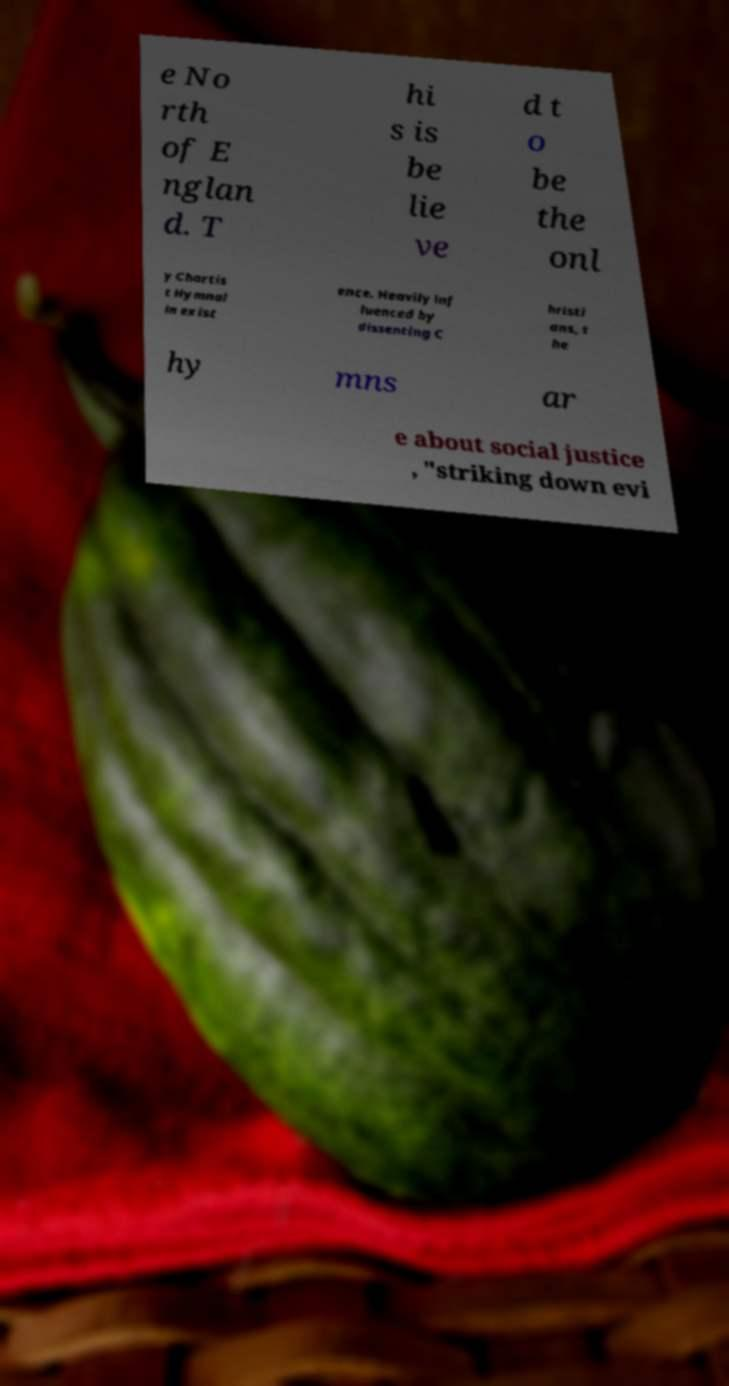For documentation purposes, I need the text within this image transcribed. Could you provide that? e No rth of E nglan d. T hi s is be lie ve d t o be the onl y Chartis t Hymnal in exist ence. Heavily inf luenced by dissenting C hristi ans, t he hy mns ar e about social justice , "striking down evi 